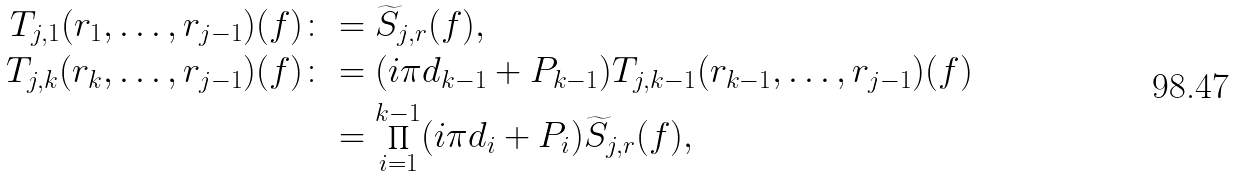<formula> <loc_0><loc_0><loc_500><loc_500>T _ { j , 1 } ( r _ { 1 } , \dots , r _ { j - 1 } ) ( f ) \colon & = \widetilde { S } _ { j , r } ( f ) , \\ T _ { j , k } ( r _ { k } , \dots , r _ { j - 1 } ) ( f ) \colon & = ( i \pi d _ { k - 1 } + P _ { k - 1 } ) T _ { j , k - 1 } ( r _ { k - 1 } , \dots , r _ { j - 1 } ) ( f ) \\ & = \prod _ { i = 1 } ^ { k - 1 } ( i \pi d _ { i } + P _ { i } ) \widetilde { S } _ { j , r } ( f ) ,</formula> 